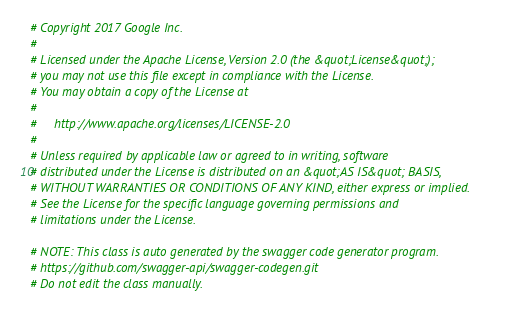Convert code to text. <code><loc_0><loc_0><loc_500><loc_500><_Elixir_># Copyright 2017 Google Inc.
#
# Licensed under the Apache License, Version 2.0 (the &quot;License&quot;);
# you may not use this file except in compliance with the License.
# You may obtain a copy of the License at
#
#     http://www.apache.org/licenses/LICENSE-2.0
#
# Unless required by applicable law or agreed to in writing, software
# distributed under the License is distributed on an &quot;AS IS&quot; BASIS,
# WITHOUT WARRANTIES OR CONDITIONS OF ANY KIND, either express or implied.
# See the License for the specific language governing permissions and
# limitations under the License.

# NOTE: This class is auto generated by the swagger code generator program.
# https://github.com/swagger-api/swagger-codegen.git
# Do not edit the class manually.
</code> 